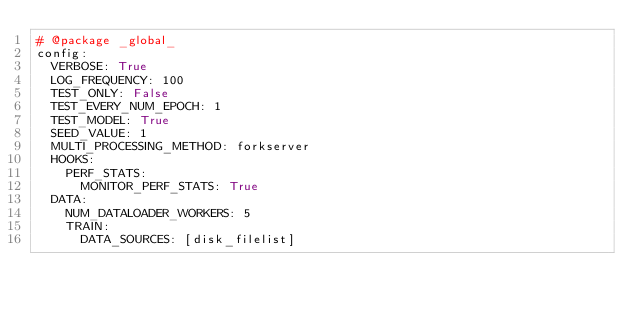Convert code to text. <code><loc_0><loc_0><loc_500><loc_500><_YAML_># @package _global_
config:
  VERBOSE: True
  LOG_FREQUENCY: 100
  TEST_ONLY: False
  TEST_EVERY_NUM_EPOCH: 1
  TEST_MODEL: True
  SEED_VALUE: 1
  MULTI_PROCESSING_METHOD: forkserver
  HOOKS:
    PERF_STATS:
      MONITOR_PERF_STATS: True
  DATA:
    NUM_DATALOADER_WORKERS: 5
    TRAIN:
      DATA_SOURCES: [disk_filelist]</code> 